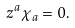<formula> <loc_0><loc_0><loc_500><loc_500>z ^ { a } \chi _ { a } = 0 .</formula> 